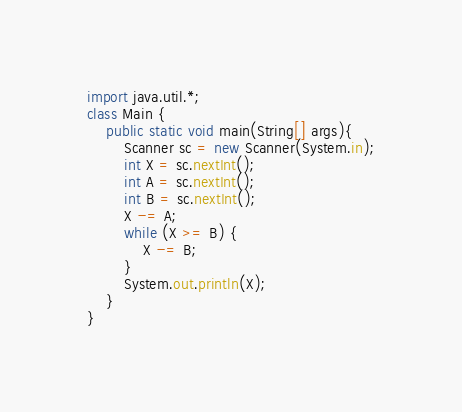Convert code to text. <code><loc_0><loc_0><loc_500><loc_500><_Java_>import java.util.*;
class Main {
	public static void main(String[] args){
		Scanner sc = new Scanner(System.in);
		int X = sc.nextInt();
		int A = sc.nextInt();
		int B = sc.nextInt();
		X -= A;
		while (X >= B) {
			X -= B;
		}
		System.out.println(X);
	}
}</code> 